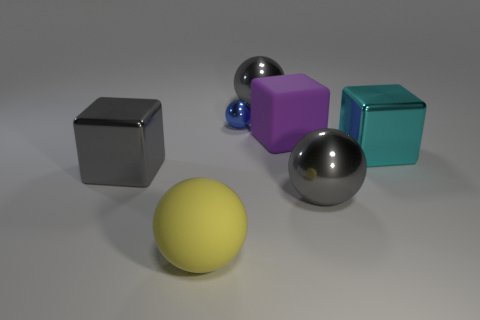Are there any other things that have the same size as the blue metal object?
Offer a terse response. No. How many large metallic objects are left of the matte block and in front of the big cyan cube?
Make the answer very short. 1. What number of cubes are big green metal things or big purple objects?
Offer a very short reply. 1. Is there a tiny red rubber ball?
Make the answer very short. No. What number of other things are made of the same material as the tiny blue sphere?
Your answer should be very brief. 4. There is a purple object that is the same size as the gray cube; what material is it?
Your answer should be very brief. Rubber. There is a big shiny object on the left side of the tiny ball; is it the same shape as the cyan metal thing?
Ensure brevity in your answer.  Yes. How many objects are either large gray metal objects to the left of the big purple cube or small blue balls?
Make the answer very short. 3. There is a yellow rubber object that is the same size as the purple cube; what shape is it?
Give a very brief answer. Sphere. Do the gray ball that is in front of the cyan shiny thing and the gray shiny object that is on the left side of the small blue sphere have the same size?
Your answer should be compact. Yes. 